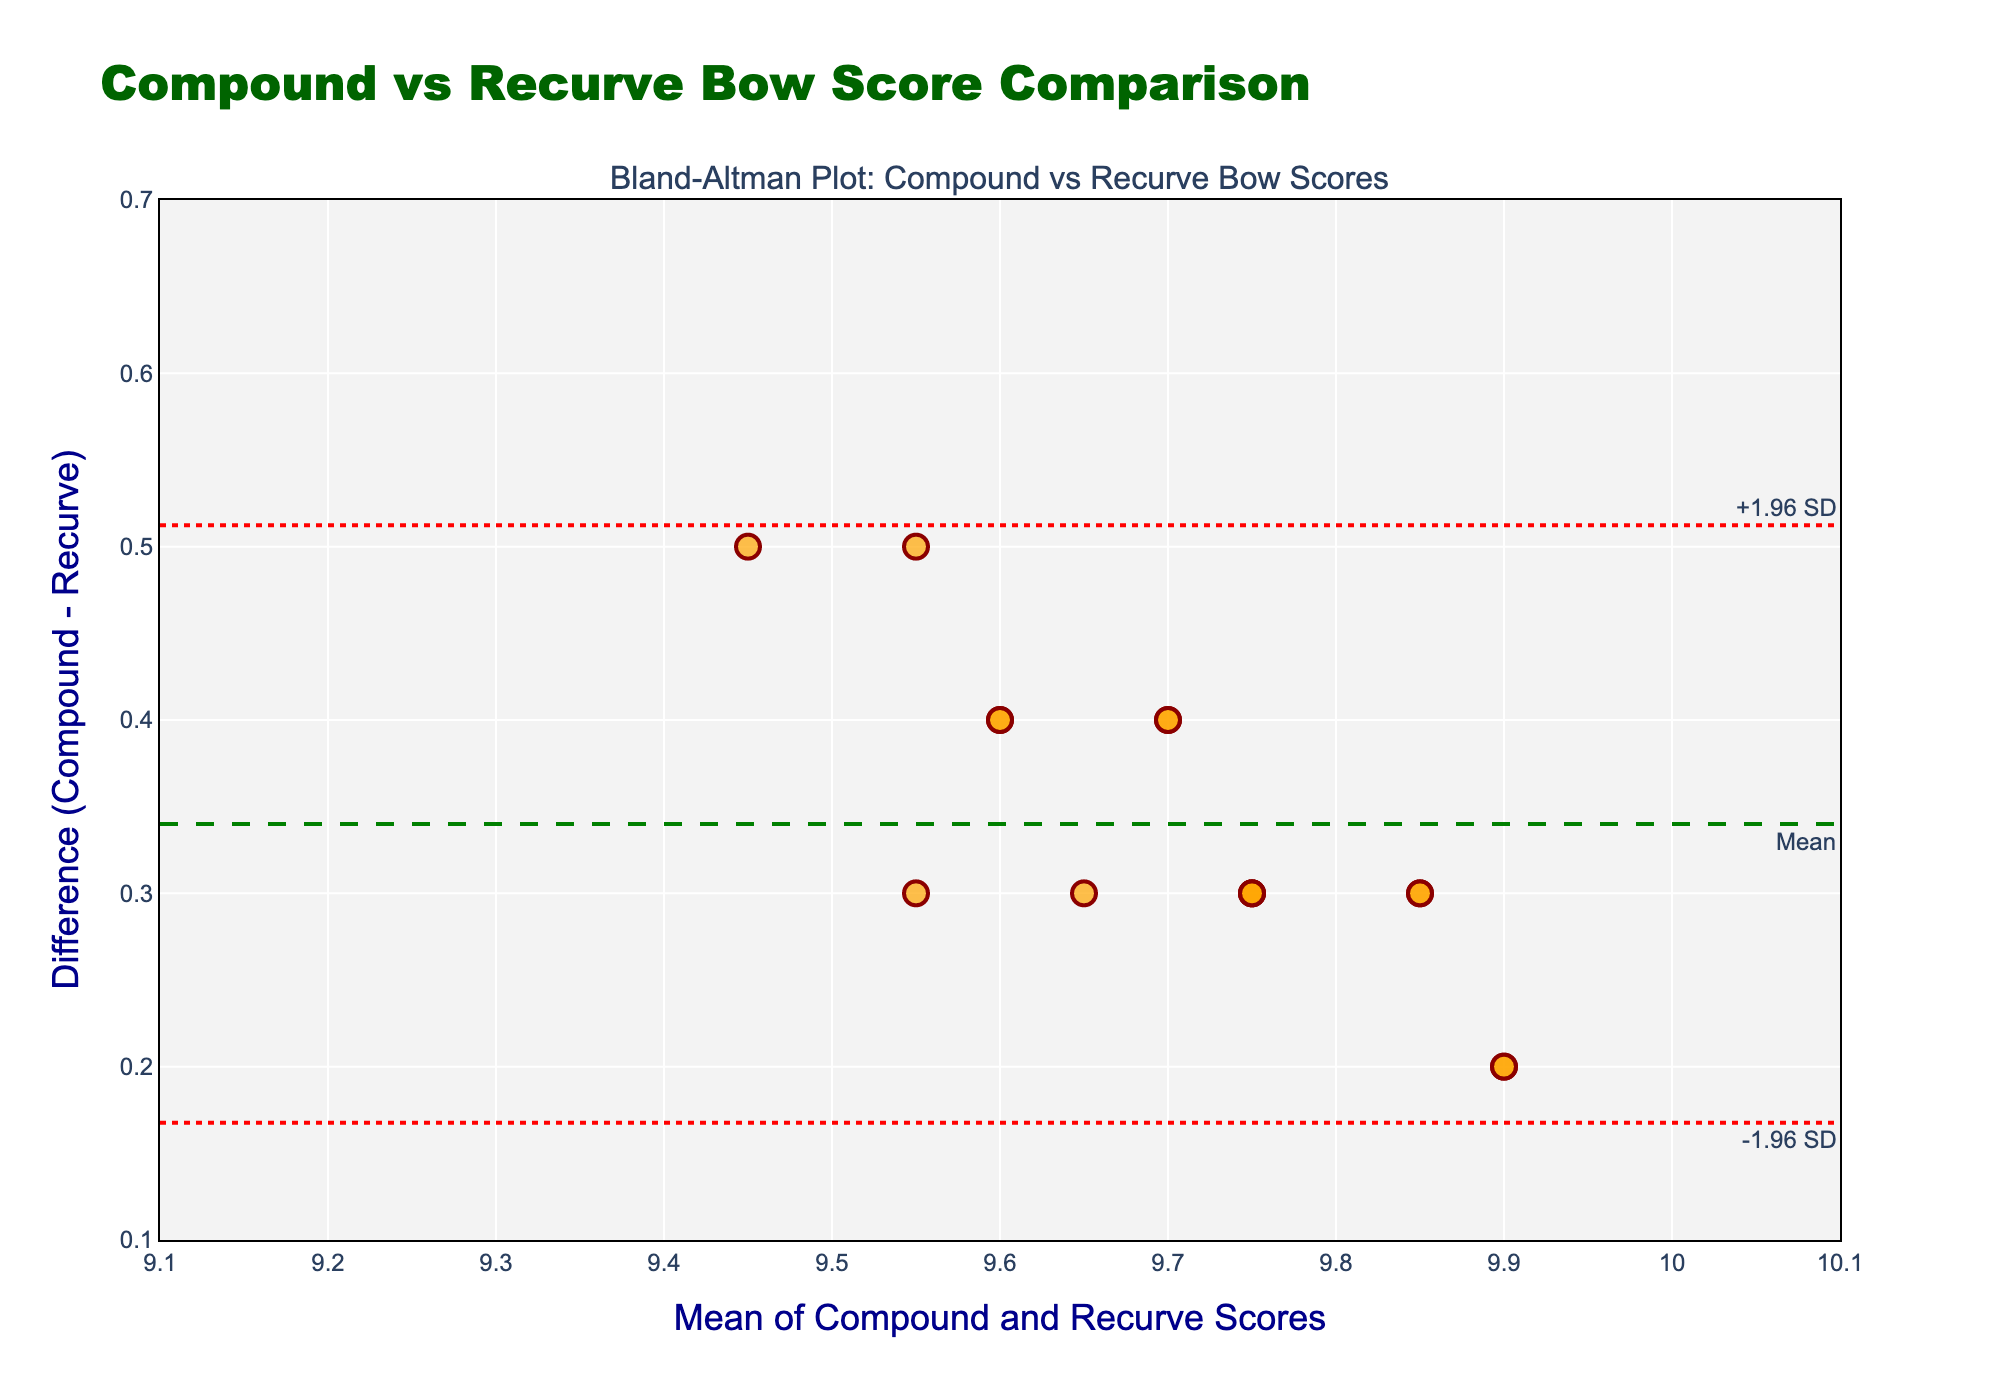What is the title of the plot? The title is usually placed at the top of the plot to indicate what it is about. In this case, the title is displayed at the top center of the plot.
Answer: Compound vs Recurve Bow Score Comparison What color are the data points in the plot? By observing the scatter points in the plot, one can see their color. These points are usually designed to stand out against the background.
Answer: Orange How many data points are there in the plot? Each data point on the plot corresponds to a measurement. Counting the points will give the number of data points.
Answer: 15 What does the x-axis represent in this plot? The x-axis typically has a label that describes what it measures. Here, it is explained in the x-axis title.
Answer: Mean of Compound and Recurve Scores What is the mean difference between compound and recurve bow scores? The mean difference is often highlighted by a dashed line in the plot. This value is usually accompanied by a label or annotation.
Answer: 0.43 What are the upper and lower limits of agreement in the plot? The upper and lower limits of agreement are marked by dotted lines and usually annotated on the plot. By finding these lines, we can determine their values.
Answer: Upper: 0.59, Lower: 0.27 What is the range of the x-axis? The range of the x-axis can be determined by looking at the minimum and maximum values displayed on the axis.
Answer: 9.1 to 10.1 What is the highest difference observed in the data points? By looking at the y-axis values of the scatter points, the point with the largest y-value represents the highest difference.
Answer: 0.53 How do compound scores generally compare to recurve scores, based on the plot? The plot shows differences between compound and recurve scores, with differences scattered around the mean difference line. An overall pattern may be seen by the distribution and sign of differences.
Answer: Compound scores are generally higher Do any of the data points lie outside the limits of agreement? To answer this, one needs to check if there are any points above the upper limit or below the lower limit on the plot.
Answer: No 